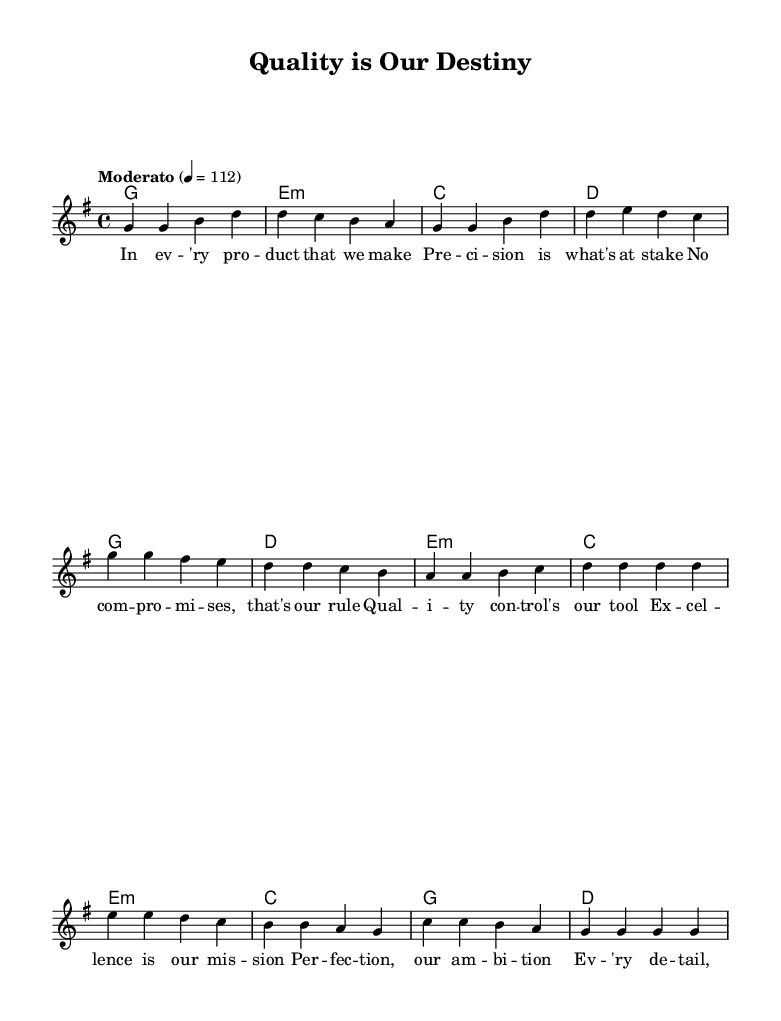What is the key signature of this music? The key signature is G major, which has one sharp (F#).
Answer: G major What is the time signature of this music? The time signature is 4/4, indicating four beats per measure.
Answer: 4/4 What is the tempo marking of this piece? The tempo marking is "Moderato," indicating a moderate speed.
Answer: Moderato How many sections are there in this piece? There are three distinct sections: Verse, Chorus, and Bridge.
Answer: Three What is the primary theme of the lyrics? The primary theme focuses on quality control and striving for excellence in production.
Answer: Quality control In which section do the lyrics emphasize "Excellence is our mission"? This line is found in the Chorus section of the song.
Answer: Chorus How does the melody change between the Verse and Chorus? The melody for the Chorus tends to rise and has a more uplifting feel compared to the Verse.
Answer: It rises and uplifts 